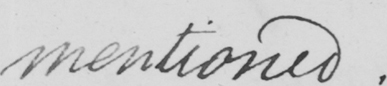Can you tell me what this handwritten text says? mentioned. 